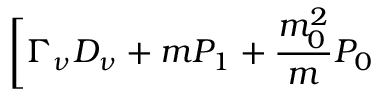Convert formula to latex. <formula><loc_0><loc_0><loc_500><loc_500>\Big [ \Gamma _ { \nu } D _ { \nu } + m P _ { 1 } + \frac { m _ { 0 } ^ { 2 } } { m } P _ { 0 }</formula> 